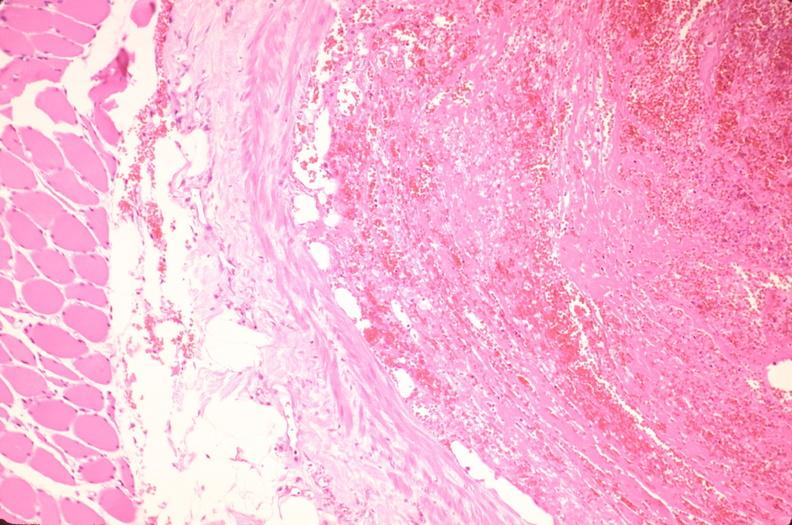s cardiovascular present?
Answer the question using a single word or phrase. Yes 